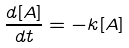Convert formula to latex. <formula><loc_0><loc_0><loc_500><loc_500>\frac { d [ A ] } { d t } = - k [ A ]</formula> 